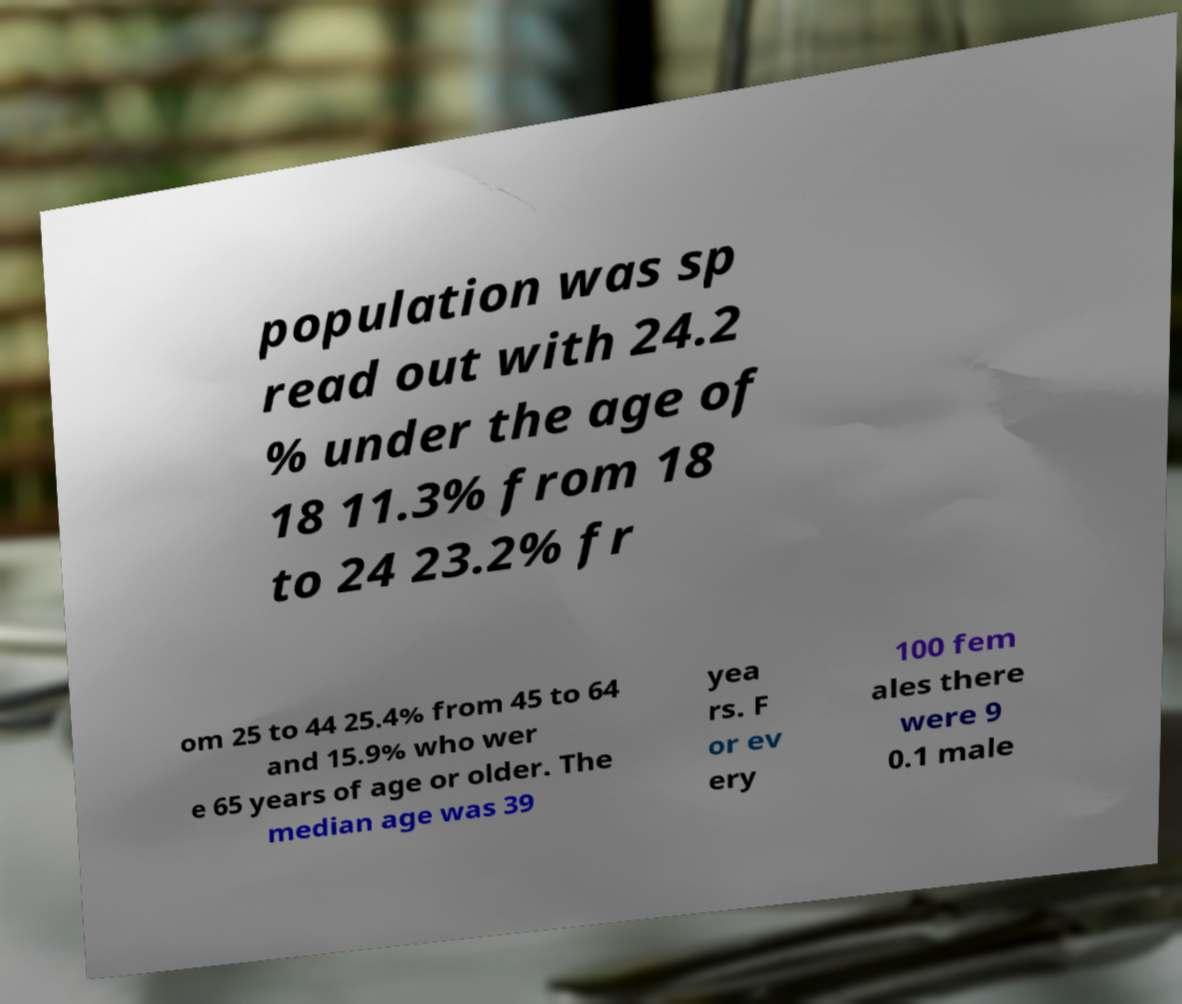Can you accurately transcribe the text from the provided image for me? population was sp read out with 24.2 % under the age of 18 11.3% from 18 to 24 23.2% fr om 25 to 44 25.4% from 45 to 64 and 15.9% who wer e 65 years of age or older. The median age was 39 yea rs. F or ev ery 100 fem ales there were 9 0.1 male 